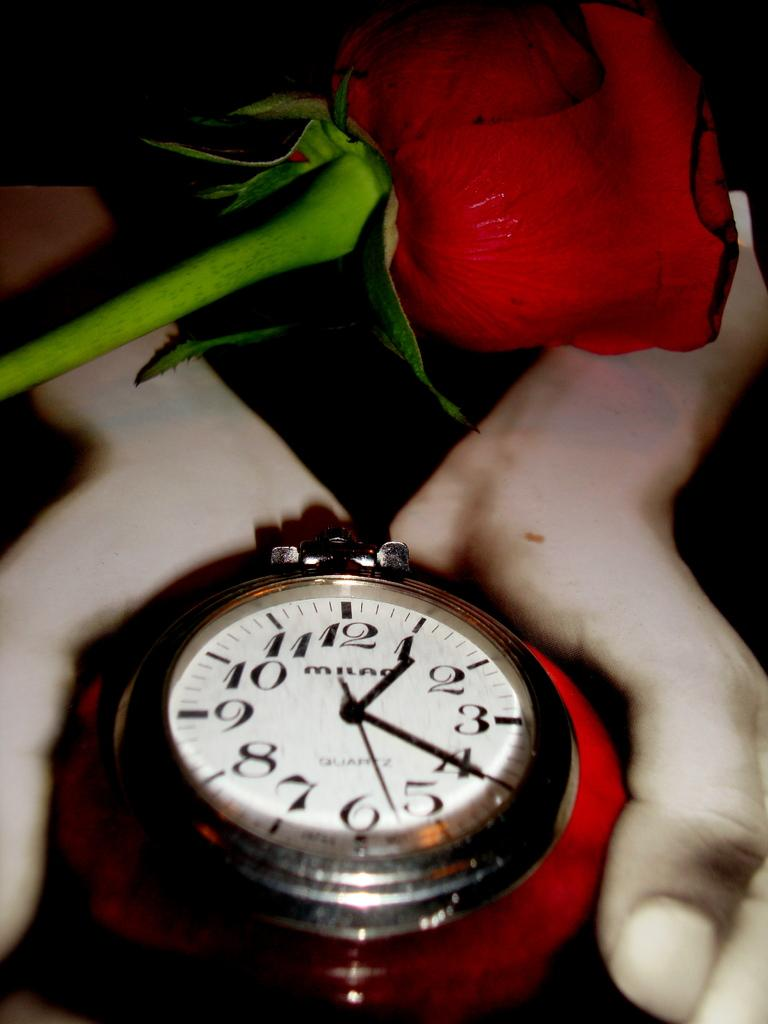Provide a one-sentence caption for the provided image. A red rose hovers over a large Milan watch. 